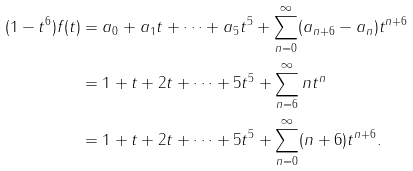Convert formula to latex. <formula><loc_0><loc_0><loc_500><loc_500>( 1 - t ^ { 6 } ) f ( t ) & = a _ { 0 } + a _ { 1 } t + \cdots + a _ { 5 } t ^ { 5 } + \sum _ { n = 0 } ^ { \infty } ( a _ { n + 6 } - a _ { n } ) t ^ { n + 6 } \\ & = 1 + t + 2 t + \cdots + 5 t ^ { 5 } + \sum _ { n = 6 } ^ { \infty } n t ^ { n } \\ & = 1 + t + 2 t + \cdots + 5 t ^ { 5 } + \sum _ { n = 0 } ^ { \infty } ( n + 6 ) t ^ { n + 6 } .</formula> 